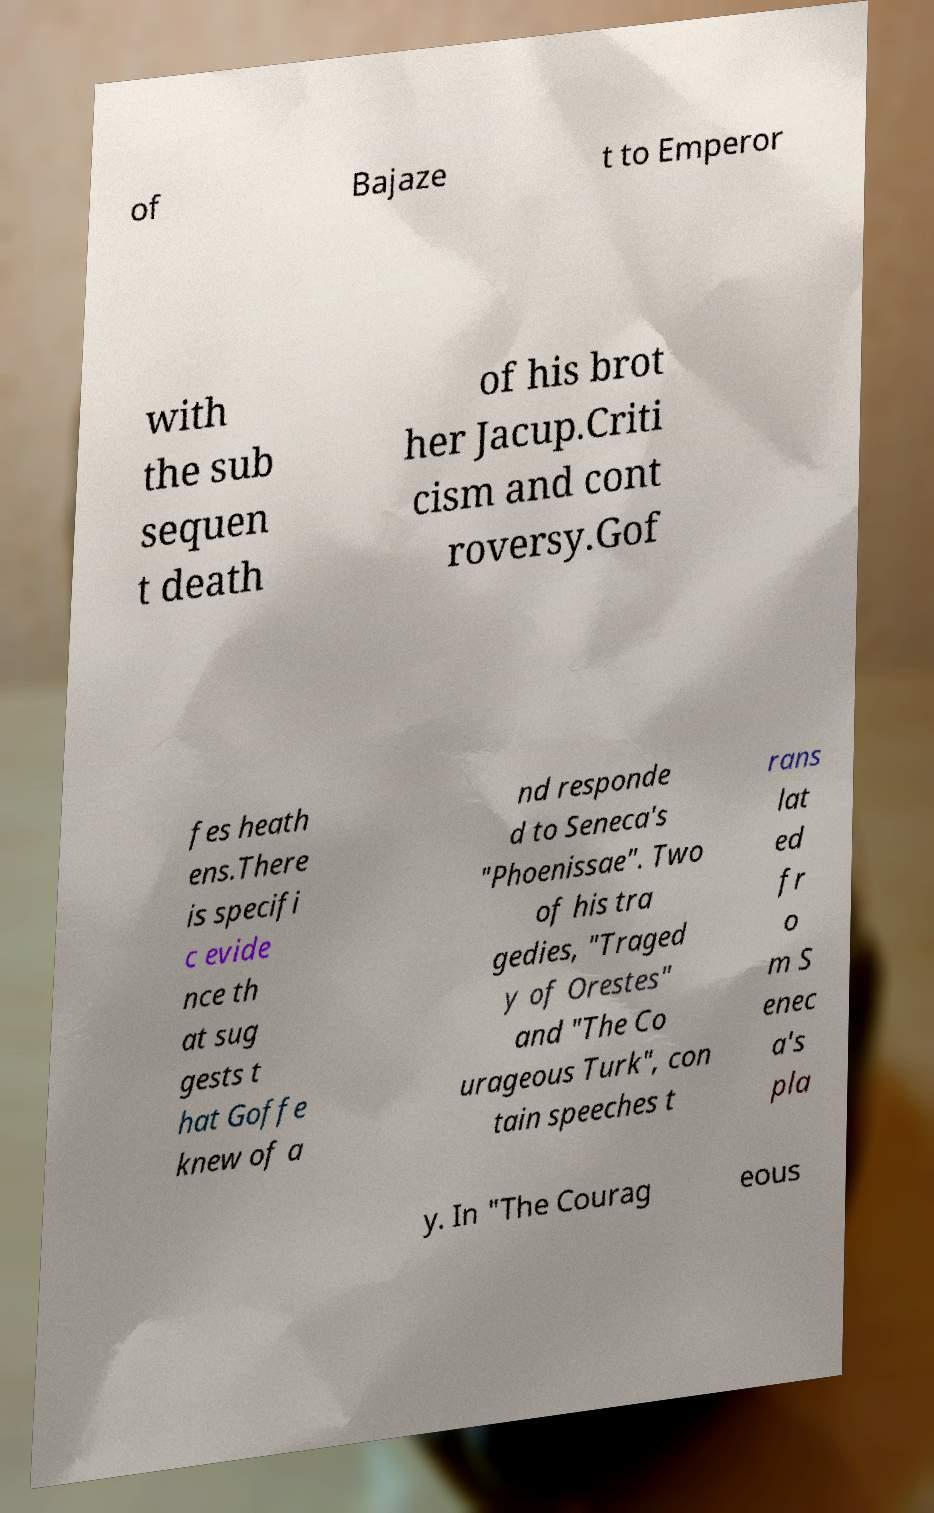Please read and relay the text visible in this image. What does it say? of Bajaze t to Emperor with the sub sequen t death of his brot her Jacup.Criti cism and cont roversy.Gof fes heath ens.There is specifi c evide nce th at sug gests t hat Goffe knew of a nd responde d to Seneca's "Phoenissae". Two of his tra gedies, "Traged y of Orestes" and "The Co urageous Turk", con tain speeches t rans lat ed fr o m S enec a's pla y. In "The Courag eous 